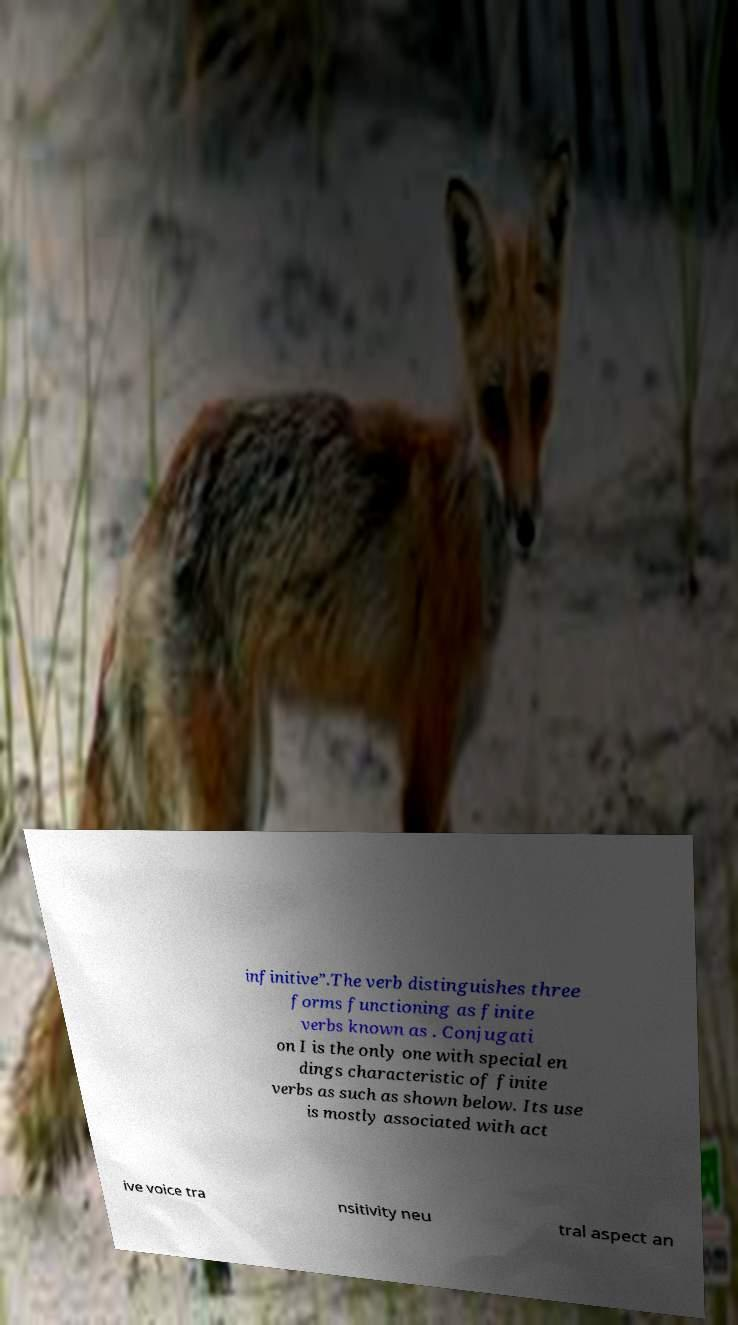Please read and relay the text visible in this image. What does it say? infinitive”.The verb distinguishes three forms functioning as finite verbs known as . Conjugati on I is the only one with special en dings characteristic of finite verbs as such as shown below. Its use is mostly associated with act ive voice tra nsitivity neu tral aspect an 